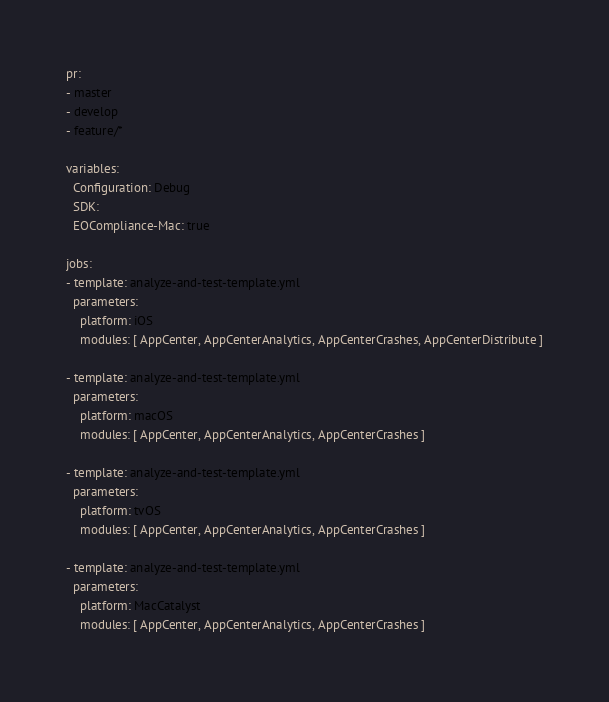<code> <loc_0><loc_0><loc_500><loc_500><_YAML_>pr:
- master
- develop
- feature/*

variables:
  Configuration: Debug
  SDK:
  EOCompliance-Mac: true

jobs:
- template: analyze-and-test-template.yml
  parameters:
    platform: iOS
    modules: [ AppCenter, AppCenterAnalytics, AppCenterCrashes, AppCenterDistribute ]

- template: analyze-and-test-template.yml
  parameters:
    platform: macOS
    modules: [ AppCenter, AppCenterAnalytics, AppCenterCrashes ]

- template: analyze-and-test-template.yml
  parameters:
    platform: tvOS
    modules: [ AppCenter, AppCenterAnalytics, AppCenterCrashes ]

- template: analyze-and-test-template.yml
  parameters:
    platform: MacCatalyst
    modules: [ AppCenter, AppCenterAnalytics, AppCenterCrashes ]
</code> 